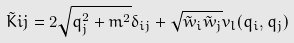Convert formula to latex. <formula><loc_0><loc_0><loc_500><loc_500>\tilde { K } { i j } = 2 \sqrt { q _ { j } ^ { 2 } + m ^ { 2 } } \delta _ { i j } + \sqrt { \tilde { w } _ { i } \tilde { w } _ { j } } v _ { l } ( q _ { i } , q _ { j } )</formula> 